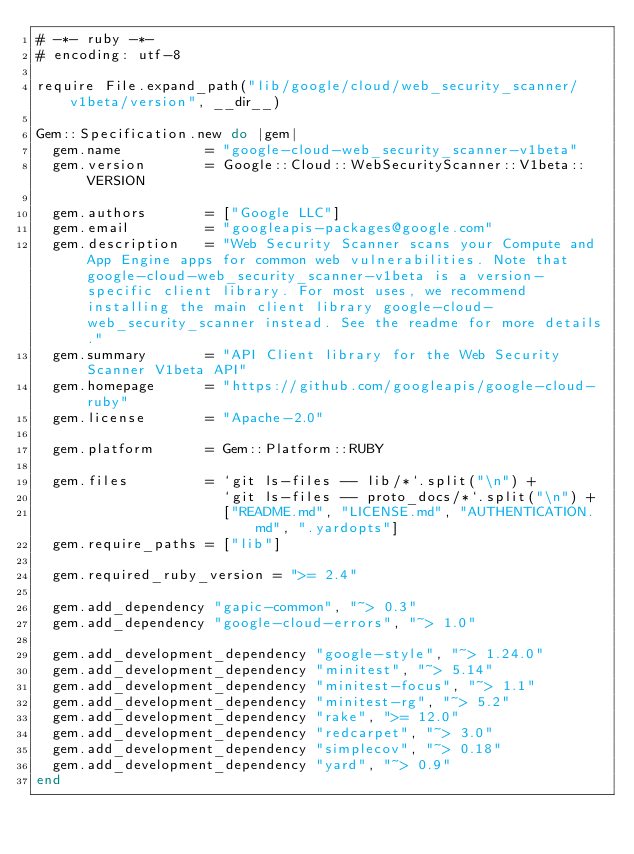<code> <loc_0><loc_0><loc_500><loc_500><_Ruby_># -*- ruby -*-
# encoding: utf-8

require File.expand_path("lib/google/cloud/web_security_scanner/v1beta/version", __dir__)

Gem::Specification.new do |gem|
  gem.name          = "google-cloud-web_security_scanner-v1beta"
  gem.version       = Google::Cloud::WebSecurityScanner::V1beta::VERSION

  gem.authors       = ["Google LLC"]
  gem.email         = "googleapis-packages@google.com"
  gem.description   = "Web Security Scanner scans your Compute and App Engine apps for common web vulnerabilities. Note that google-cloud-web_security_scanner-v1beta is a version-specific client library. For most uses, we recommend installing the main client library google-cloud-web_security_scanner instead. See the readme for more details."
  gem.summary       = "API Client library for the Web Security Scanner V1beta API"
  gem.homepage      = "https://github.com/googleapis/google-cloud-ruby"
  gem.license       = "Apache-2.0"

  gem.platform      = Gem::Platform::RUBY

  gem.files         = `git ls-files -- lib/*`.split("\n") +
                      `git ls-files -- proto_docs/*`.split("\n") +
                      ["README.md", "LICENSE.md", "AUTHENTICATION.md", ".yardopts"]
  gem.require_paths = ["lib"]

  gem.required_ruby_version = ">= 2.4"

  gem.add_dependency "gapic-common", "~> 0.3"
  gem.add_dependency "google-cloud-errors", "~> 1.0"

  gem.add_development_dependency "google-style", "~> 1.24.0"
  gem.add_development_dependency "minitest", "~> 5.14"
  gem.add_development_dependency "minitest-focus", "~> 1.1"
  gem.add_development_dependency "minitest-rg", "~> 5.2"
  gem.add_development_dependency "rake", ">= 12.0"
  gem.add_development_dependency "redcarpet", "~> 3.0"
  gem.add_development_dependency "simplecov", "~> 0.18"
  gem.add_development_dependency "yard", "~> 0.9"
end
</code> 